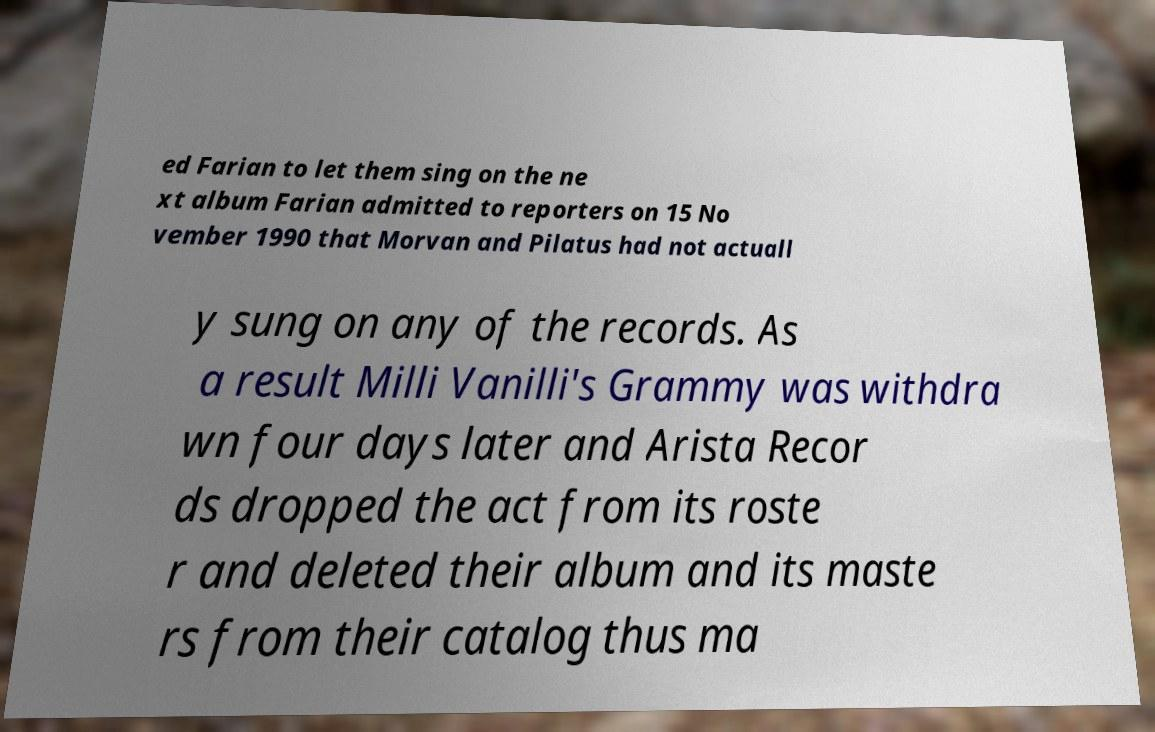Could you assist in decoding the text presented in this image and type it out clearly? ed Farian to let them sing on the ne xt album Farian admitted to reporters on 15 No vember 1990 that Morvan and Pilatus had not actuall y sung on any of the records. As a result Milli Vanilli's Grammy was withdra wn four days later and Arista Recor ds dropped the act from its roste r and deleted their album and its maste rs from their catalog thus ma 